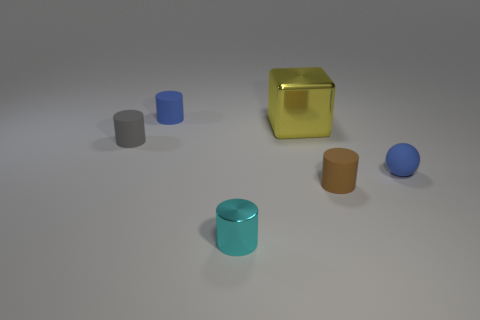Subtract all green cylinders. Subtract all green spheres. How many cylinders are left? 4 Add 1 small blue rubber cylinders. How many objects exist? 7 Subtract all blocks. How many objects are left? 5 Subtract 0 blue cubes. How many objects are left? 6 Subtract all large metallic cubes. Subtract all yellow shiny objects. How many objects are left? 4 Add 5 brown matte things. How many brown matte things are left? 6 Add 3 tiny cylinders. How many tiny cylinders exist? 7 